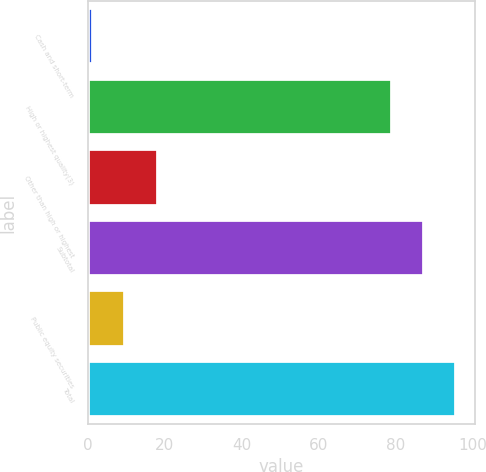Convert chart. <chart><loc_0><loc_0><loc_500><loc_500><bar_chart><fcel>Cash and short-term<fcel>High or highest quality(3)<fcel>Other than high or highest<fcel>Subtotal<fcel>Public equity securities<fcel>Total<nl><fcel>1.4<fcel>79<fcel>18.18<fcel>87.39<fcel>9.79<fcel>95.78<nl></chart> 